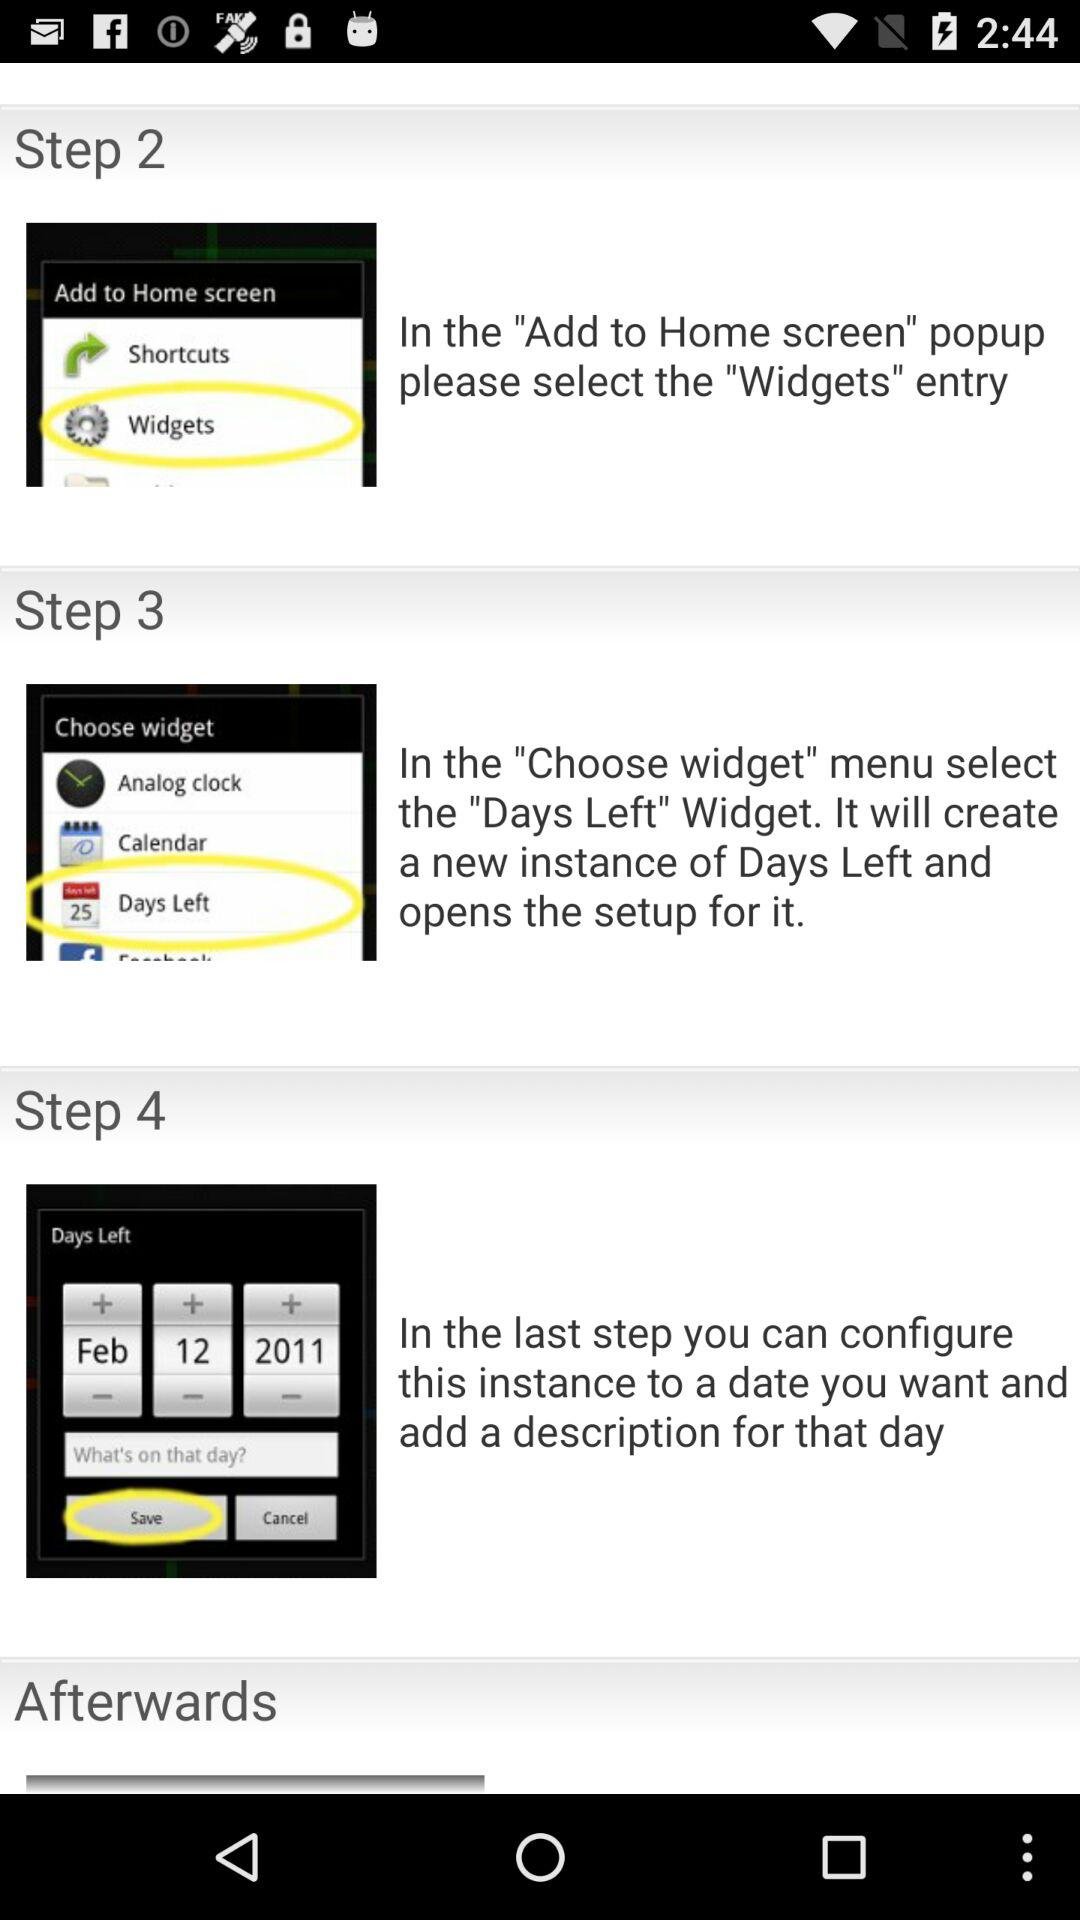How many steps are there in the process?
Answer the question using a single word or phrase. 4 